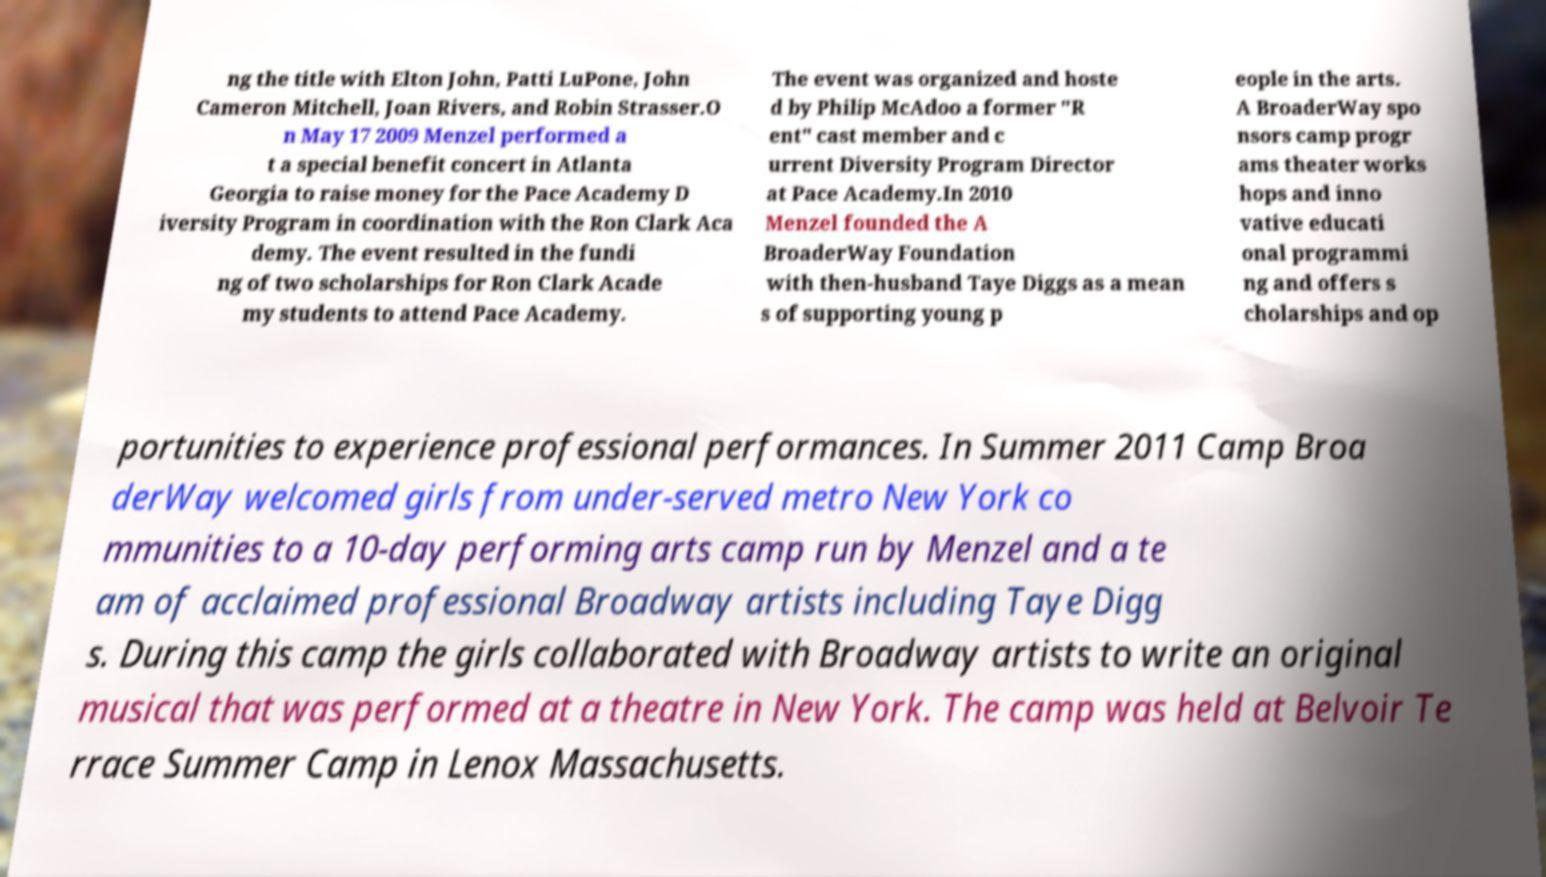Can you accurately transcribe the text from the provided image for me? ng the title with Elton John, Patti LuPone, John Cameron Mitchell, Joan Rivers, and Robin Strasser.O n May 17 2009 Menzel performed a t a special benefit concert in Atlanta Georgia to raise money for the Pace Academy D iversity Program in coordination with the Ron Clark Aca demy. The event resulted in the fundi ng of two scholarships for Ron Clark Acade my students to attend Pace Academy. The event was organized and hoste d by Philip McAdoo a former "R ent" cast member and c urrent Diversity Program Director at Pace Academy.In 2010 Menzel founded the A BroaderWay Foundation with then-husband Taye Diggs as a mean s of supporting young p eople in the arts. A BroaderWay spo nsors camp progr ams theater works hops and inno vative educati onal programmi ng and offers s cholarships and op portunities to experience professional performances. In Summer 2011 Camp Broa derWay welcomed girls from under-served metro New York co mmunities to a 10-day performing arts camp run by Menzel and a te am of acclaimed professional Broadway artists including Taye Digg s. During this camp the girls collaborated with Broadway artists to write an original musical that was performed at a theatre in New York. The camp was held at Belvoir Te rrace Summer Camp in Lenox Massachusetts. 